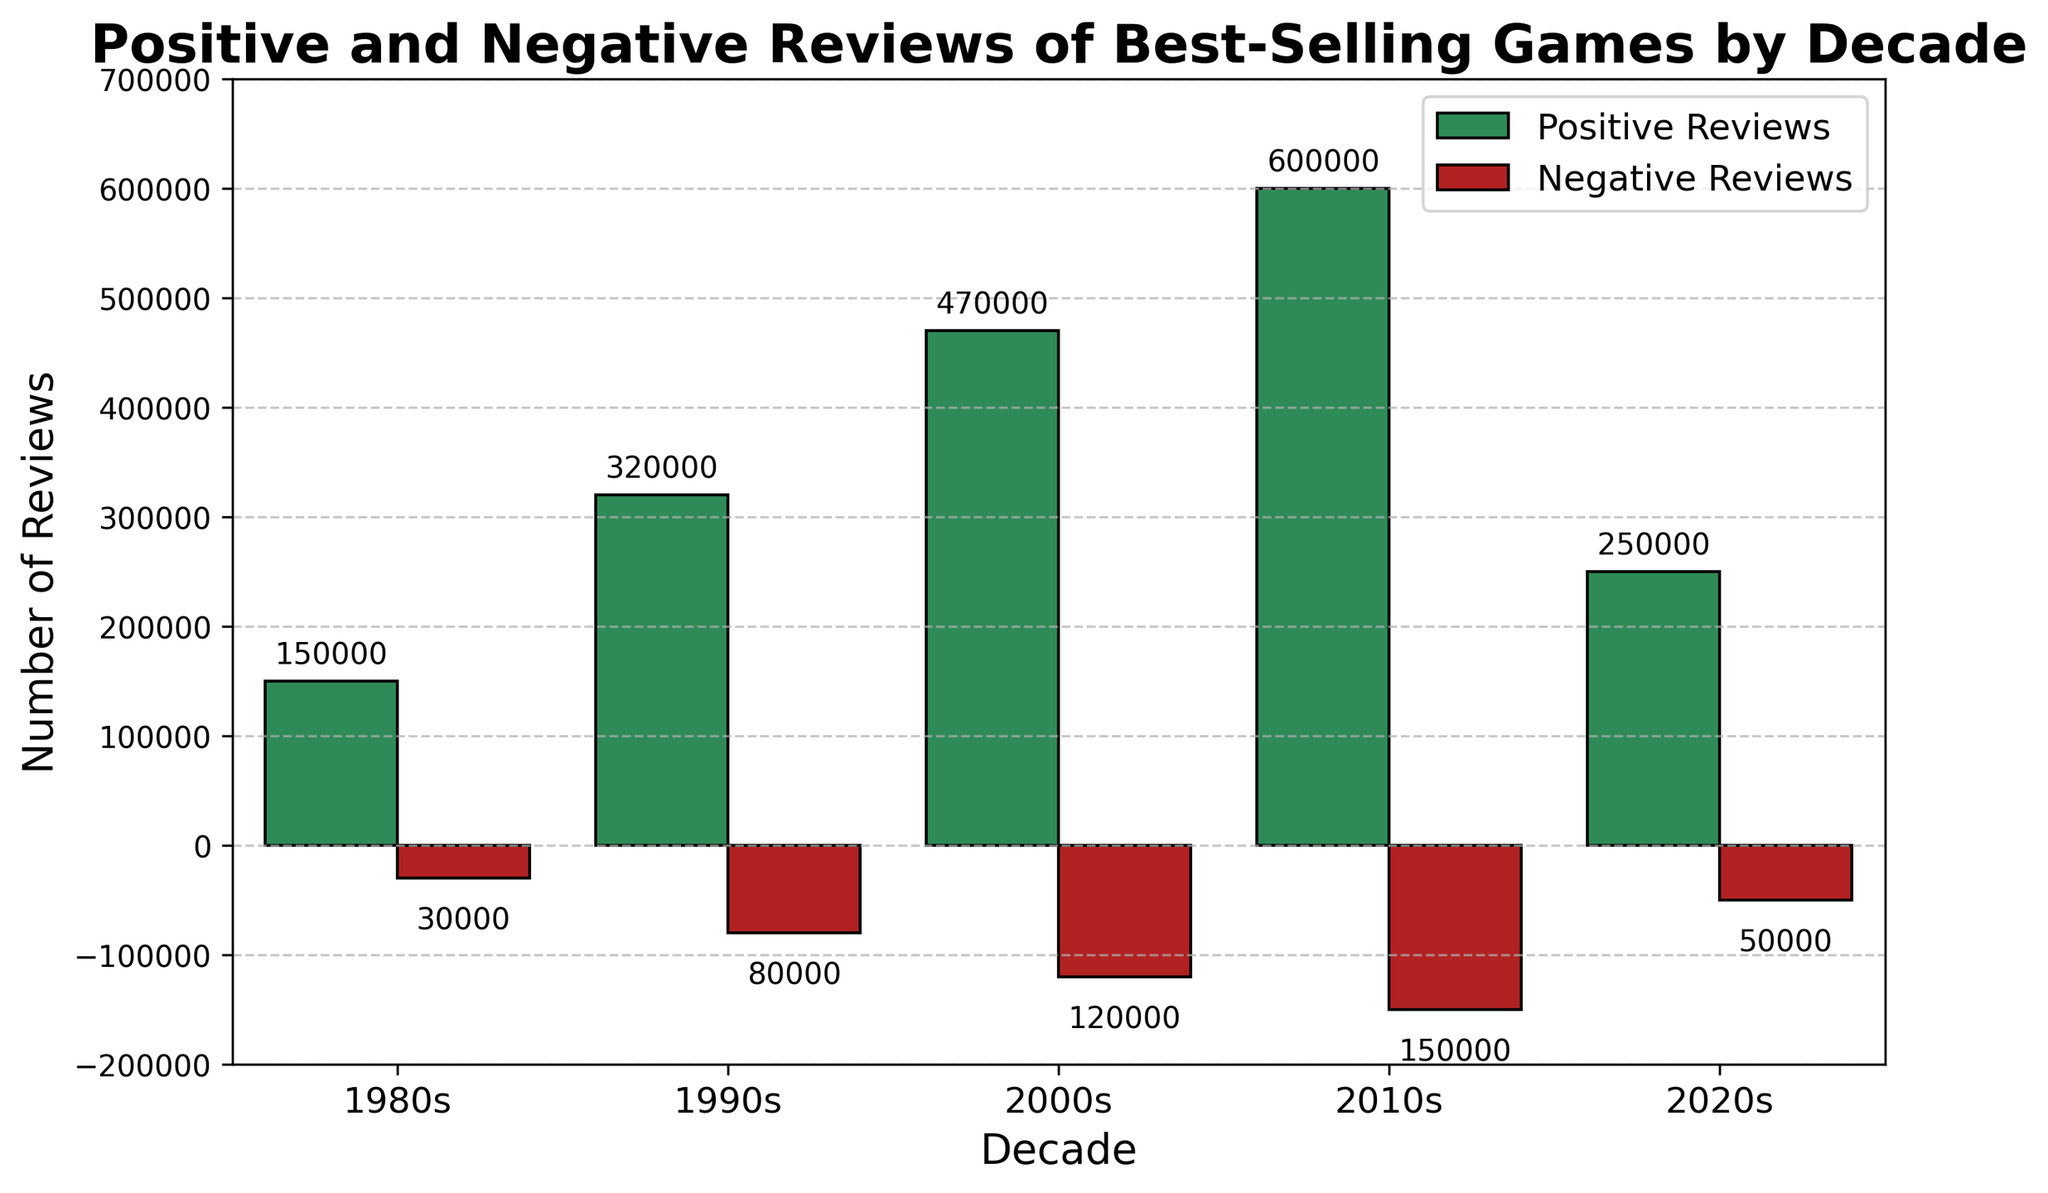Which decade had the highest number of positive reviews? Look at the bars representing positive reviews and compare their heights. The tallest bar for positive reviews corresponds to the 2010s, which is 600,000.
Answer: 2010s Which decade had the lowest number of negative reviews? Look at the bars representing negative reviews and compare their heights. The shortest bar for negative reviews corresponds to the 1980s, which is 30,000.
Answer: 1980s What are the total number of reviews (positive and negative) in the 2000s? Sum the positive and negative reviews for the 2000s. Positive reviews are 470,000 and negative reviews are 120,000. So, 470,000 + 120,000 = 590,000.
Answer: 590,000 How does the number of positive reviews in the 2020s compare to the number of negative reviews in the 2010s? Compare the positive reviews in the 2020s (250,000) to the negative reviews in the 2010s (150,000). The positive reviews in the 2020s are 100,000 more.
Answer: The 2020s positive reviews are 100,000 more What is the average number of positive reviews per decade? Add up all the positive reviews (150,000 + 320,000 + 470,000 + 600,000 + 250,000) and divide by the number of decades (5). So, (150,000 + 320,000 + 470,000 + 600,000 + 250,000) / 5 = 358,000.
Answer: 358,000 Which decade had the largest difference between positive and negative reviews? Calculate the difference between positive and negative reviews for each decade and compare. The differences are:
- 1980s: 150,000 - 30,000 = 120,000
- 1990s: 320,000 - 80,000 = 240,000
- 2000s: 470,000 - 120,000 = 350,000
- 2010s: 600,000 - 150,000 = 450,000
- 2020s: 250,000 - 50,000 = 200,000
The largest difference is in the 2010s, with 450,000.
Answer: 2010s Which decade has the greater growth in positive reviews compared to the previous decade? Calculate the growth in positive reviews for each transitioning decade:
- 1980s to 1990s: 320,000 - 150,000 = 170,000
- 1990s to 2000s: 470,000 - 320,000 = 150,000
- 2000s to 2010s: 600,000 - 470,000 = 130,000
- 2010s to 2020s: 250,000 - 600,000 = -350,000
The greatest growth is from the 1980s to the 1990s, with an increase of 170,000.
Answer: 1980s to 1990s What is the ratio of positive to negative reviews in the 1990s? Divide the positive reviews by the negative reviews for the 1990s. Positive reviews are 320,000 and negative reviews are 80,000. So, 320,000 / 80,000 = 4.
Answer: 4 How much did the number of positive reviews increase from the 1980s to the 2010s? Subtract the number of positive reviews in the 1980s from the number of positive reviews in the 2010s. 600,000 - 150,000 = 450,000.
Answer: 450,000 What percentage of total reviews were negative in the 2020s? Calculate the percentage of negative reviews out of the total reviews in the 2020s. Total reviews are 250,000 (positive) + 50,000 (negative) = 300,000. The percentage is (50,000 / 300,000) * 100 = approximately 16.67%.
Answer: 16.67% 